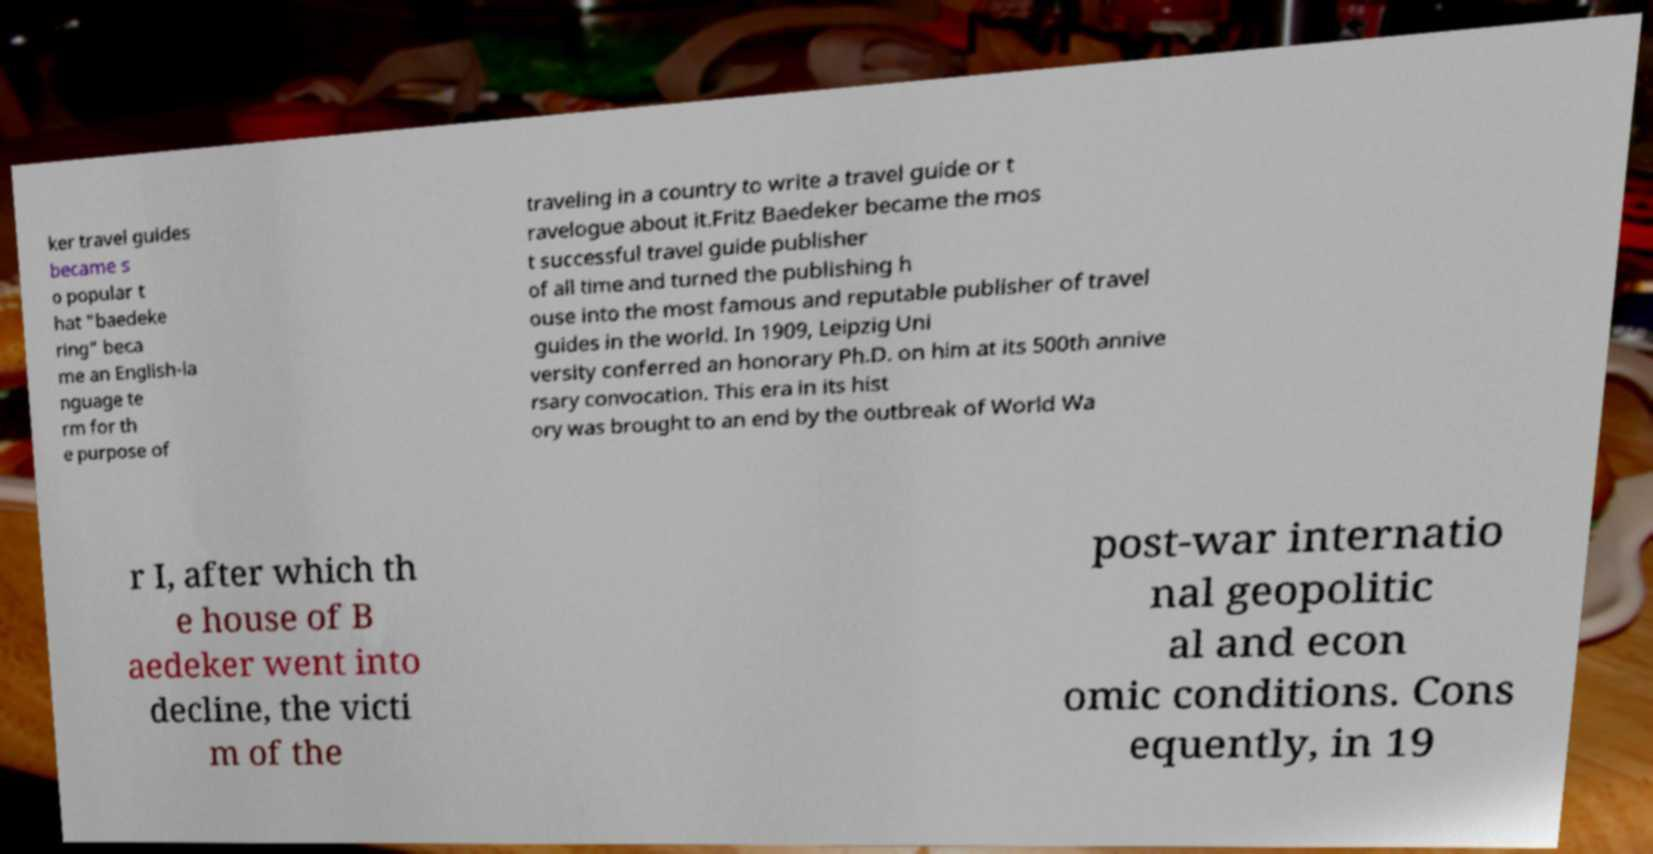I need the written content from this picture converted into text. Can you do that? ker travel guides became s o popular t hat "baedeke ring" beca me an English-la nguage te rm for th e purpose of traveling in a country to write a travel guide or t ravelogue about it.Fritz Baedeker became the mos t successful travel guide publisher of all time and turned the publishing h ouse into the most famous and reputable publisher of travel guides in the world. In 1909, Leipzig Uni versity conferred an honorary Ph.D. on him at its 500th annive rsary convocation. This era in its hist ory was brought to an end by the outbreak of World Wa r I, after which th e house of B aedeker went into decline, the victi m of the post-war internatio nal geopolitic al and econ omic conditions. Cons equently, in 19 